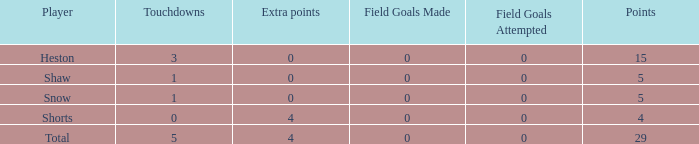What is the sum of all the touchdowns when the player had more than 0 extra points and less than 0 field goals? None. Could you parse the entire table as a dict? {'header': ['Player', 'Touchdowns', 'Extra points', 'Field Goals Made', 'Field Goals Attempted', 'Points'], 'rows': [['Heston', '3', '0', '0', '0', '15'], ['Shaw', '1', '0', '0', '0', '5'], ['Snow', '1', '0', '0', '0', '5'], ['Shorts', '0', '4', '0', '0', '4'], ['Total', '5', '4', '0', '0', '29']]} 